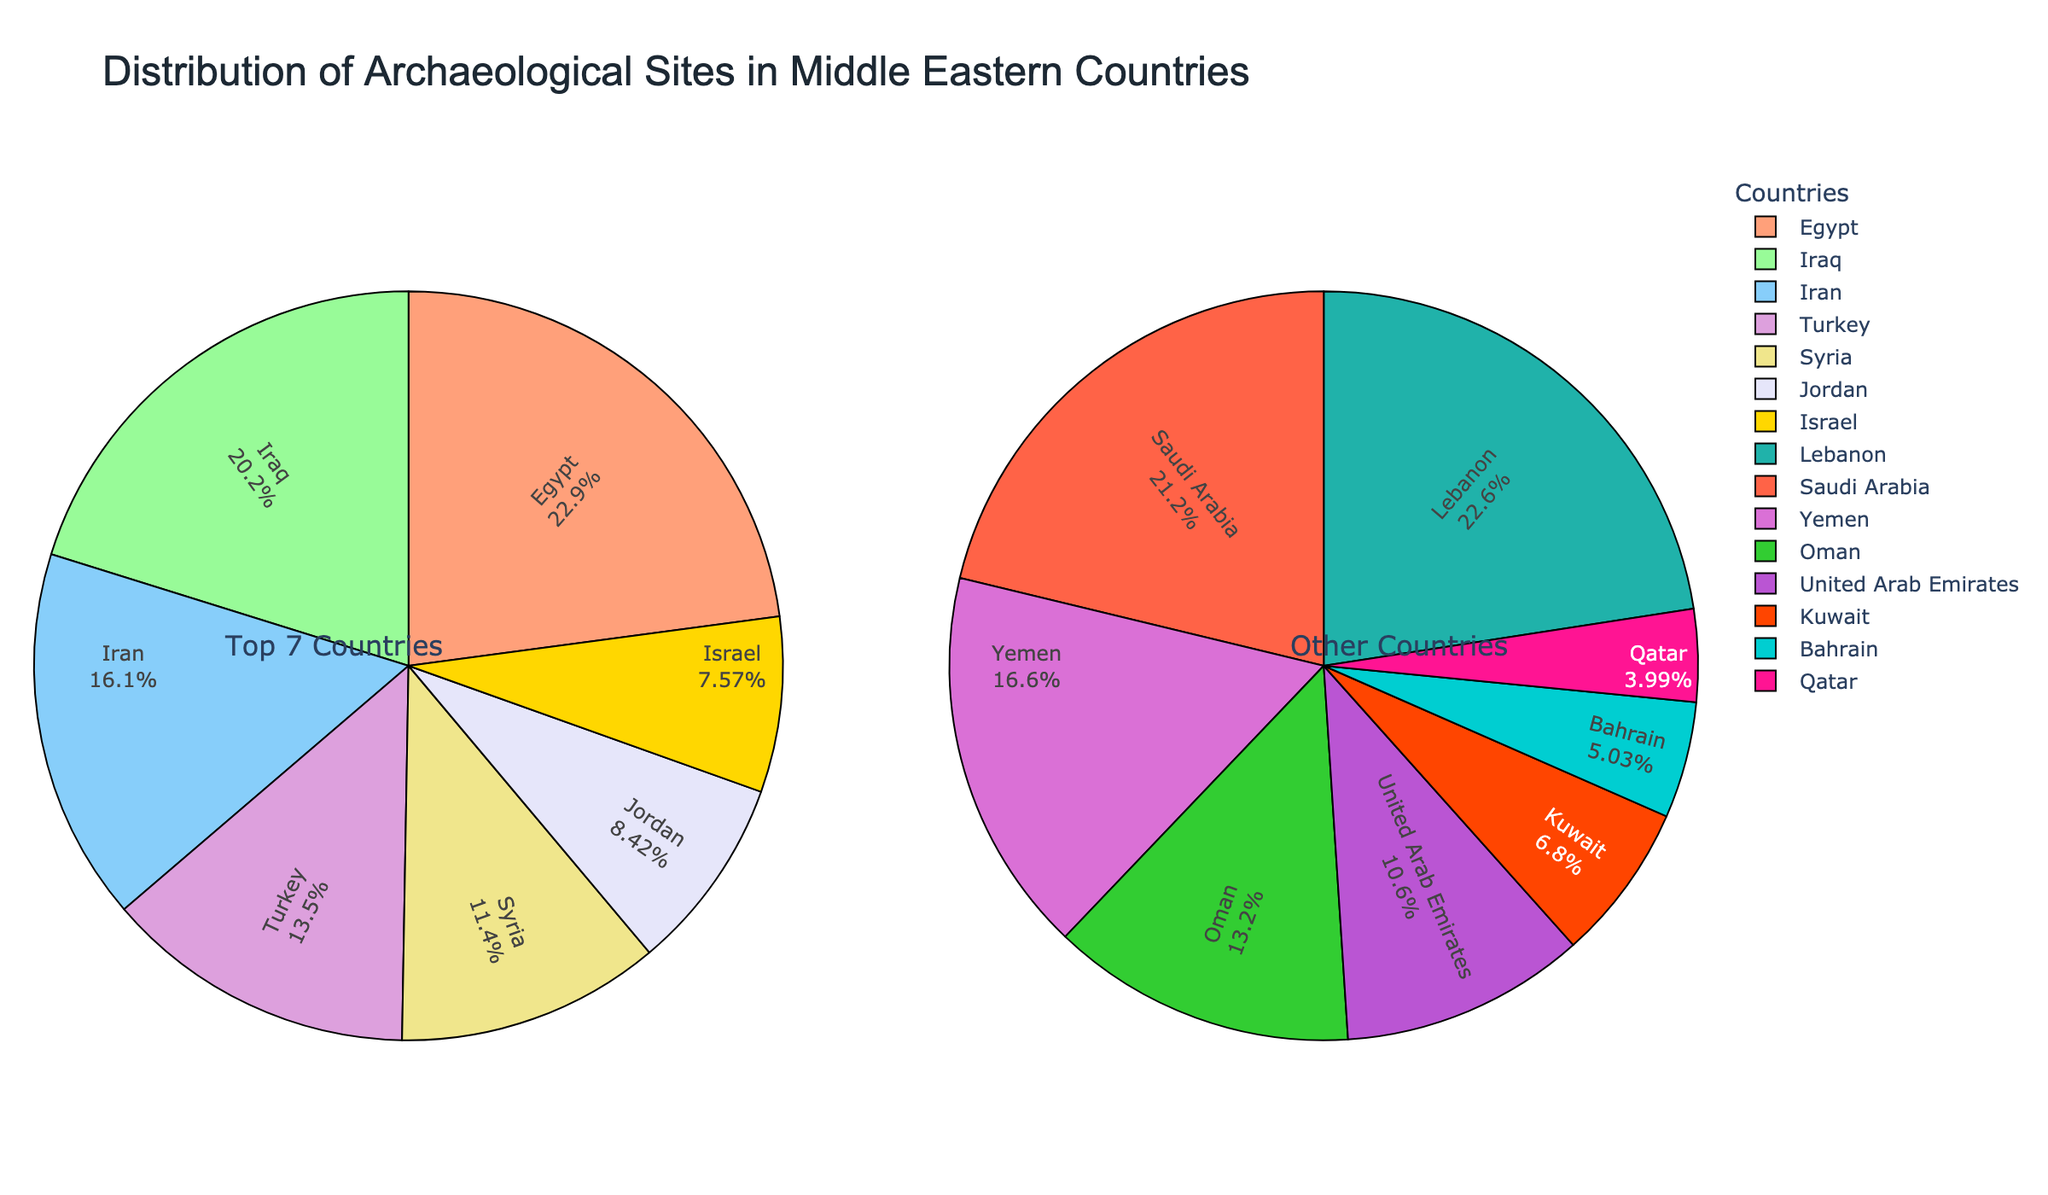Which country has the highest number of archaeological sites? By observing the pie chart, Egypt clearly occupies the largest segment in the 'Top 7 Countries' category. Thus, Egypt has the highest number of archaeological sites.
Answer: Egypt What percentage of archaeological sites does Saudi Arabia have in comparison to Lebanon? Using the 'Other Countries' pie chart, the relative sizes can be compared. Saudi Arabia has a slightly larger segment than Lebanon, indicating a higher percentage of the total.
Answer: Higher Between Jordan and Israel, which country has more archaeological sites and by how many? Referencing the 'Top 7 Countries' pie chart, Jordan's segment is larger than Israel's. Jordan has 458 sites and Israel 412, thus Jordan has 458 - 412 = 46 more sites.
Answer: Jordan, 46 What is the combined percentage of archaeological sites in Egypt, Iraq, and Iran compared to the total top 7 countries? The pie chart for 'Top 7 Countries' shows the percentages for Egypt, Iraq, and Iran. Summing them gives us 29.3% (Egypt) + 25.9% (Iraq) + 20.6% (Iran) = 75.8%.
Answer: 75.8% How does the number of archaeological sites in Oman compare to the UAE? From the 'Other Countries' pie chart, Oman has a larger segment than the UAE, indicating that Oman has more archaeological sites.
Answer: More Which segment in the 'Top 7 Countries' pie chart is in green? Observing the colors, the 'green' segment corresponds to Iraq, as per the color assignments.
Answer: Iraq What are the combined number of archaeological sites in Syria, Jordan, and Israel? From the 'Top 7 Countries' chart: Syria (620) + Jordan (458) + Israel (412) = 1490.
Answer: 1490 If Bahrain and Qatar were combined into one category, what percentage would they represent of the 'Other Countries'? The pie chart shows Bahrain and Qatar with 68 and 54 sites respectively. Combined, they add to 122. This needs to be divided by the total of the 'Other Countries' to find the percentage, i.e., (122 / (287 + 225 + 178 + 143 + 92 + 68 + 54)) * 100 = 11.8%.
Answer: 11.8% Which country has the smallest segment in the 'Top 7 Countries' pie chart? Israel has the smallest segment within the 'Top 7 Countries'.
Answer: Israel How does the visual distribution in the 'Top 7 Countries' compare to the 'Other Countries' pie chart in terms of balance? The 'Top 7 Countries' pie chart has larger and unevenly distributed segments indicating larger discrepancies in the number of sites among the top countries. The 'Other Countries' pie chart shows more balanced distribution among segments, each comparatively smaller.
Answer: More balanced in 'Other Countries' 